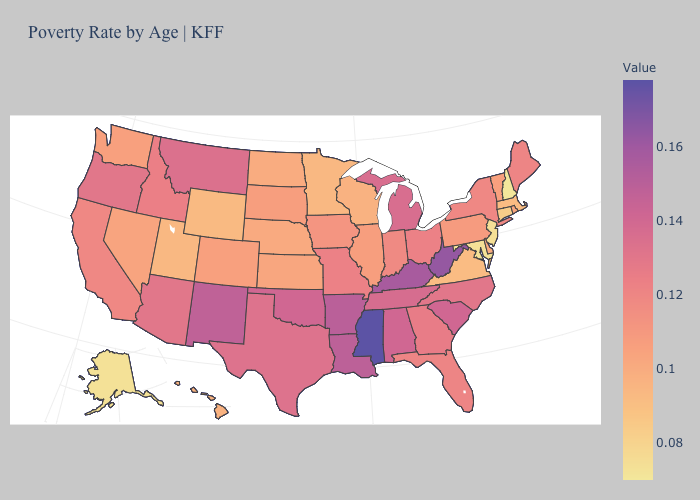Does Arizona have a higher value than North Dakota?
Give a very brief answer. Yes. Is the legend a continuous bar?
Write a very short answer. Yes. Among the states that border Kentucky , which have the lowest value?
Write a very short answer. Virginia. 